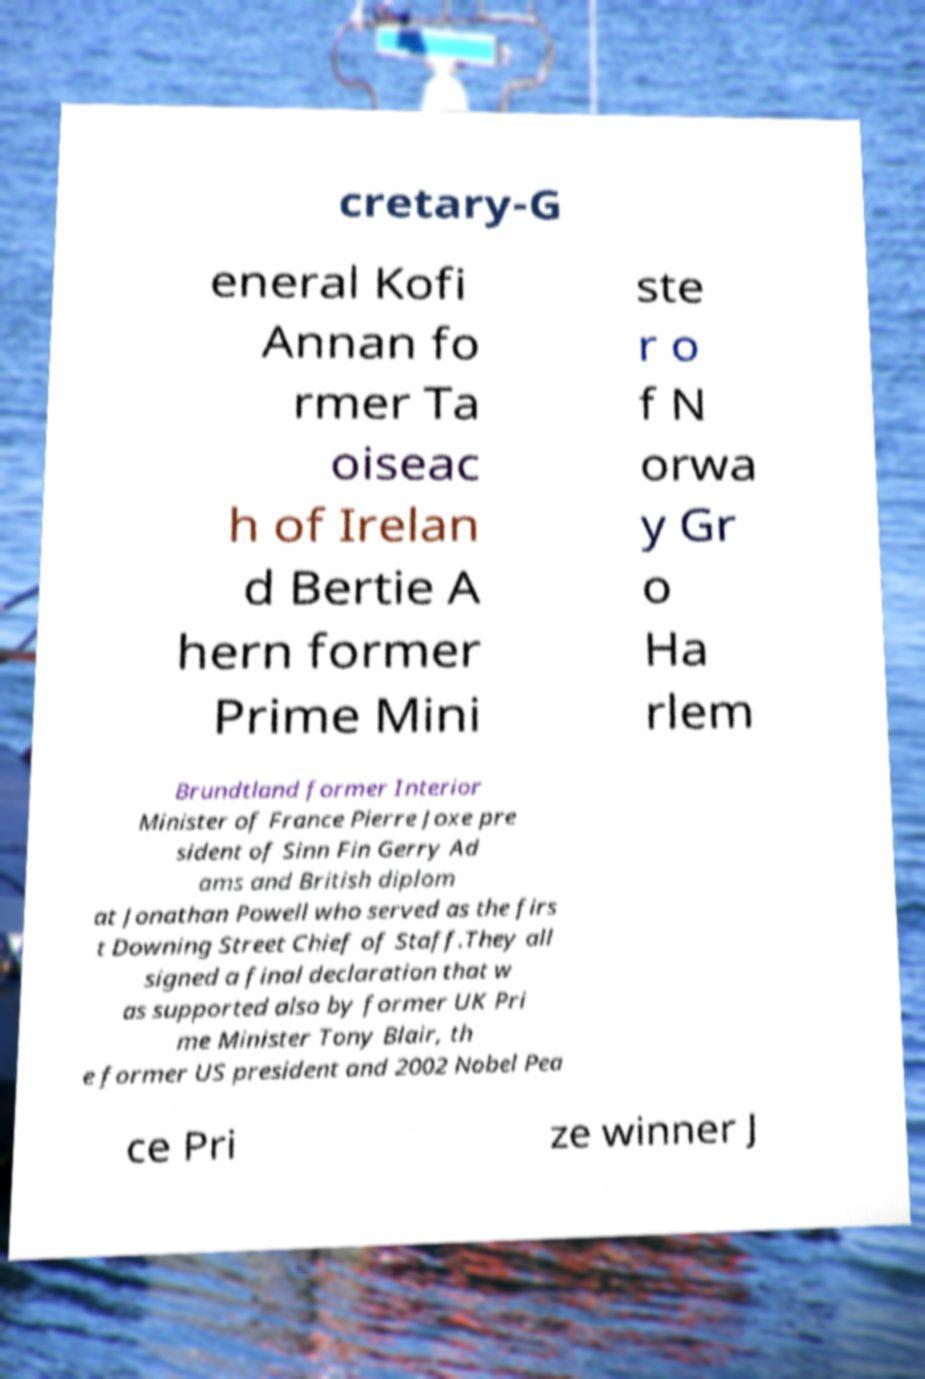Please identify and transcribe the text found in this image. cretary-G eneral Kofi Annan fo rmer Ta oiseac h of Irelan d Bertie A hern former Prime Mini ste r o f N orwa y Gr o Ha rlem Brundtland former Interior Minister of France Pierre Joxe pre sident of Sinn Fin Gerry Ad ams and British diplom at Jonathan Powell who served as the firs t Downing Street Chief of Staff.They all signed a final declaration that w as supported also by former UK Pri me Minister Tony Blair, th e former US president and 2002 Nobel Pea ce Pri ze winner J 